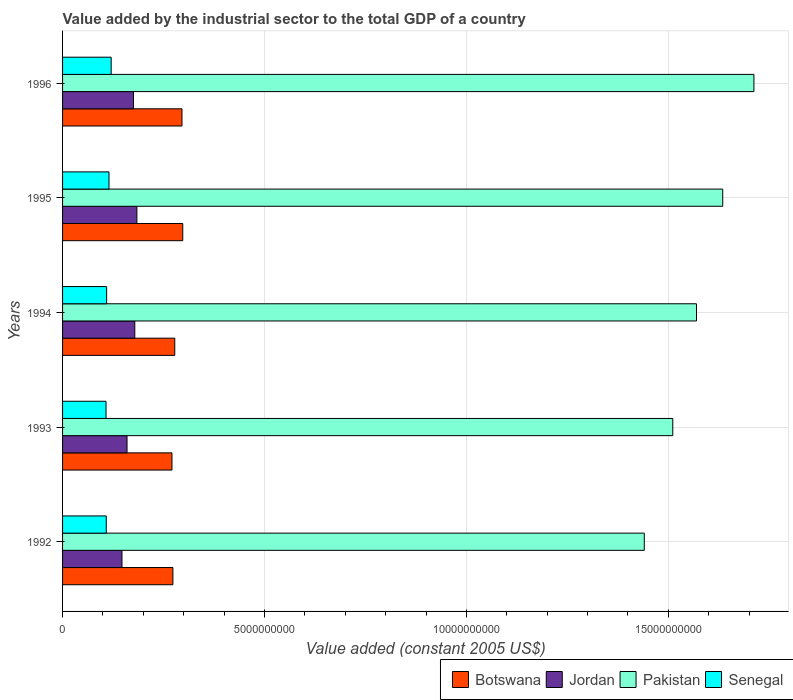How many different coloured bars are there?
Your answer should be very brief. 4. How many groups of bars are there?
Keep it short and to the point. 5. Are the number of bars on each tick of the Y-axis equal?
Make the answer very short. Yes. How many bars are there on the 2nd tick from the top?
Your answer should be compact. 4. What is the label of the 5th group of bars from the top?
Your response must be concise. 1992. In how many cases, is the number of bars for a given year not equal to the number of legend labels?
Ensure brevity in your answer.  0. What is the value added by the industrial sector in Senegal in 1992?
Your response must be concise. 1.08e+09. Across all years, what is the maximum value added by the industrial sector in Senegal?
Give a very brief answer. 1.20e+09. Across all years, what is the minimum value added by the industrial sector in Jordan?
Provide a succinct answer. 1.47e+09. In which year was the value added by the industrial sector in Jordan maximum?
Your answer should be very brief. 1995. In which year was the value added by the industrial sector in Botswana minimum?
Offer a very short reply. 1993. What is the total value added by the industrial sector in Pakistan in the graph?
Make the answer very short. 7.87e+1. What is the difference between the value added by the industrial sector in Pakistan in 1992 and that in 1994?
Your answer should be compact. -1.29e+09. What is the difference between the value added by the industrial sector in Jordan in 1993 and the value added by the industrial sector in Botswana in 1996?
Ensure brevity in your answer.  -1.36e+09. What is the average value added by the industrial sector in Senegal per year?
Your answer should be compact. 1.12e+09. In the year 1993, what is the difference between the value added by the industrial sector in Botswana and value added by the industrial sector in Pakistan?
Your response must be concise. -1.24e+1. What is the ratio of the value added by the industrial sector in Botswana in 1994 to that in 1995?
Provide a succinct answer. 0.93. What is the difference between the highest and the second highest value added by the industrial sector in Senegal?
Your answer should be compact. 5.38e+07. What is the difference between the highest and the lowest value added by the industrial sector in Botswana?
Ensure brevity in your answer.  2.67e+08. In how many years, is the value added by the industrial sector in Pakistan greater than the average value added by the industrial sector in Pakistan taken over all years?
Your answer should be compact. 2. Is it the case that in every year, the sum of the value added by the industrial sector in Senegal and value added by the industrial sector in Pakistan is greater than the sum of value added by the industrial sector in Jordan and value added by the industrial sector in Botswana?
Offer a terse response. No. What does the 4th bar from the top in 1994 represents?
Give a very brief answer. Botswana. What does the 3rd bar from the bottom in 1994 represents?
Provide a short and direct response. Pakistan. Are all the bars in the graph horizontal?
Keep it short and to the point. Yes. What is the difference between two consecutive major ticks on the X-axis?
Provide a succinct answer. 5.00e+09. Are the values on the major ticks of X-axis written in scientific E-notation?
Make the answer very short. No. Does the graph contain any zero values?
Your answer should be very brief. No. How many legend labels are there?
Keep it short and to the point. 4. How are the legend labels stacked?
Make the answer very short. Horizontal. What is the title of the graph?
Your answer should be very brief. Value added by the industrial sector to the total GDP of a country. What is the label or title of the X-axis?
Provide a succinct answer. Value added (constant 2005 US$). What is the label or title of the Y-axis?
Make the answer very short. Years. What is the Value added (constant 2005 US$) of Botswana in 1992?
Your answer should be very brief. 2.73e+09. What is the Value added (constant 2005 US$) of Jordan in 1992?
Your answer should be compact. 1.47e+09. What is the Value added (constant 2005 US$) in Pakistan in 1992?
Your answer should be compact. 1.44e+1. What is the Value added (constant 2005 US$) of Senegal in 1992?
Provide a short and direct response. 1.08e+09. What is the Value added (constant 2005 US$) in Botswana in 1993?
Provide a short and direct response. 2.71e+09. What is the Value added (constant 2005 US$) of Jordan in 1993?
Provide a short and direct response. 1.60e+09. What is the Value added (constant 2005 US$) in Pakistan in 1993?
Keep it short and to the point. 1.51e+1. What is the Value added (constant 2005 US$) of Senegal in 1993?
Provide a succinct answer. 1.08e+09. What is the Value added (constant 2005 US$) in Botswana in 1994?
Offer a very short reply. 2.78e+09. What is the Value added (constant 2005 US$) of Jordan in 1994?
Your response must be concise. 1.79e+09. What is the Value added (constant 2005 US$) of Pakistan in 1994?
Offer a terse response. 1.57e+1. What is the Value added (constant 2005 US$) in Senegal in 1994?
Your response must be concise. 1.09e+09. What is the Value added (constant 2005 US$) in Botswana in 1995?
Your response must be concise. 2.98e+09. What is the Value added (constant 2005 US$) of Jordan in 1995?
Provide a short and direct response. 1.84e+09. What is the Value added (constant 2005 US$) of Pakistan in 1995?
Your response must be concise. 1.63e+1. What is the Value added (constant 2005 US$) of Senegal in 1995?
Provide a succinct answer. 1.15e+09. What is the Value added (constant 2005 US$) in Botswana in 1996?
Your answer should be compact. 2.96e+09. What is the Value added (constant 2005 US$) of Jordan in 1996?
Offer a very short reply. 1.76e+09. What is the Value added (constant 2005 US$) of Pakistan in 1996?
Your answer should be very brief. 1.71e+1. What is the Value added (constant 2005 US$) of Senegal in 1996?
Ensure brevity in your answer.  1.20e+09. Across all years, what is the maximum Value added (constant 2005 US$) in Botswana?
Offer a terse response. 2.98e+09. Across all years, what is the maximum Value added (constant 2005 US$) of Jordan?
Keep it short and to the point. 1.84e+09. Across all years, what is the maximum Value added (constant 2005 US$) in Pakistan?
Your answer should be very brief. 1.71e+1. Across all years, what is the maximum Value added (constant 2005 US$) in Senegal?
Make the answer very short. 1.20e+09. Across all years, what is the minimum Value added (constant 2005 US$) in Botswana?
Ensure brevity in your answer.  2.71e+09. Across all years, what is the minimum Value added (constant 2005 US$) in Jordan?
Provide a succinct answer. 1.47e+09. Across all years, what is the minimum Value added (constant 2005 US$) of Pakistan?
Provide a short and direct response. 1.44e+1. Across all years, what is the minimum Value added (constant 2005 US$) in Senegal?
Offer a terse response. 1.08e+09. What is the total Value added (constant 2005 US$) of Botswana in the graph?
Provide a short and direct response. 1.42e+1. What is the total Value added (constant 2005 US$) of Jordan in the graph?
Give a very brief answer. 8.45e+09. What is the total Value added (constant 2005 US$) in Pakistan in the graph?
Provide a short and direct response. 7.87e+1. What is the total Value added (constant 2005 US$) in Senegal in the graph?
Offer a very short reply. 5.60e+09. What is the difference between the Value added (constant 2005 US$) in Botswana in 1992 and that in 1993?
Your response must be concise. 2.29e+07. What is the difference between the Value added (constant 2005 US$) of Jordan in 1992 and that in 1993?
Your answer should be very brief. -1.25e+08. What is the difference between the Value added (constant 2005 US$) in Pakistan in 1992 and that in 1993?
Provide a succinct answer. -7.05e+08. What is the difference between the Value added (constant 2005 US$) in Senegal in 1992 and that in 1993?
Your answer should be compact. 5.36e+06. What is the difference between the Value added (constant 2005 US$) in Botswana in 1992 and that in 1994?
Give a very brief answer. -4.63e+07. What is the difference between the Value added (constant 2005 US$) in Jordan in 1992 and that in 1994?
Keep it short and to the point. -3.17e+08. What is the difference between the Value added (constant 2005 US$) in Pakistan in 1992 and that in 1994?
Your answer should be very brief. -1.29e+09. What is the difference between the Value added (constant 2005 US$) of Senegal in 1992 and that in 1994?
Offer a very short reply. -9.48e+06. What is the difference between the Value added (constant 2005 US$) in Botswana in 1992 and that in 1995?
Make the answer very short. -2.44e+08. What is the difference between the Value added (constant 2005 US$) in Jordan in 1992 and that in 1995?
Offer a terse response. -3.69e+08. What is the difference between the Value added (constant 2005 US$) in Pakistan in 1992 and that in 1995?
Your answer should be compact. -1.94e+09. What is the difference between the Value added (constant 2005 US$) of Senegal in 1992 and that in 1995?
Provide a short and direct response. -6.81e+07. What is the difference between the Value added (constant 2005 US$) in Botswana in 1992 and that in 1996?
Your answer should be compact. -2.25e+08. What is the difference between the Value added (constant 2005 US$) of Jordan in 1992 and that in 1996?
Provide a succinct answer. -2.85e+08. What is the difference between the Value added (constant 2005 US$) in Pakistan in 1992 and that in 1996?
Offer a terse response. -2.71e+09. What is the difference between the Value added (constant 2005 US$) in Senegal in 1992 and that in 1996?
Your answer should be very brief. -1.22e+08. What is the difference between the Value added (constant 2005 US$) of Botswana in 1993 and that in 1994?
Your response must be concise. -6.92e+07. What is the difference between the Value added (constant 2005 US$) in Jordan in 1993 and that in 1994?
Provide a succinct answer. -1.92e+08. What is the difference between the Value added (constant 2005 US$) in Pakistan in 1993 and that in 1994?
Your answer should be very brief. -5.87e+08. What is the difference between the Value added (constant 2005 US$) in Senegal in 1993 and that in 1994?
Offer a terse response. -1.48e+07. What is the difference between the Value added (constant 2005 US$) in Botswana in 1993 and that in 1995?
Your answer should be very brief. -2.67e+08. What is the difference between the Value added (constant 2005 US$) in Jordan in 1993 and that in 1995?
Keep it short and to the point. -2.44e+08. What is the difference between the Value added (constant 2005 US$) in Pakistan in 1993 and that in 1995?
Your answer should be compact. -1.24e+09. What is the difference between the Value added (constant 2005 US$) of Senegal in 1993 and that in 1995?
Make the answer very short. -7.35e+07. What is the difference between the Value added (constant 2005 US$) in Botswana in 1993 and that in 1996?
Your answer should be compact. -2.48e+08. What is the difference between the Value added (constant 2005 US$) in Jordan in 1993 and that in 1996?
Your answer should be compact. -1.60e+08. What is the difference between the Value added (constant 2005 US$) of Pakistan in 1993 and that in 1996?
Give a very brief answer. -2.01e+09. What is the difference between the Value added (constant 2005 US$) in Senegal in 1993 and that in 1996?
Your response must be concise. -1.27e+08. What is the difference between the Value added (constant 2005 US$) in Botswana in 1994 and that in 1995?
Offer a terse response. -1.98e+08. What is the difference between the Value added (constant 2005 US$) in Jordan in 1994 and that in 1995?
Provide a succinct answer. -5.17e+07. What is the difference between the Value added (constant 2005 US$) in Pakistan in 1994 and that in 1995?
Make the answer very short. -6.50e+08. What is the difference between the Value added (constant 2005 US$) in Senegal in 1994 and that in 1995?
Make the answer very short. -5.86e+07. What is the difference between the Value added (constant 2005 US$) of Botswana in 1994 and that in 1996?
Make the answer very short. -1.79e+08. What is the difference between the Value added (constant 2005 US$) of Jordan in 1994 and that in 1996?
Make the answer very short. 3.27e+07. What is the difference between the Value added (constant 2005 US$) of Pakistan in 1994 and that in 1996?
Offer a terse response. -1.42e+09. What is the difference between the Value added (constant 2005 US$) of Senegal in 1994 and that in 1996?
Offer a very short reply. -1.12e+08. What is the difference between the Value added (constant 2005 US$) in Botswana in 1995 and that in 1996?
Provide a succinct answer. 1.96e+07. What is the difference between the Value added (constant 2005 US$) of Jordan in 1995 and that in 1996?
Keep it short and to the point. 8.45e+07. What is the difference between the Value added (constant 2005 US$) of Pakistan in 1995 and that in 1996?
Ensure brevity in your answer.  -7.72e+08. What is the difference between the Value added (constant 2005 US$) in Senegal in 1995 and that in 1996?
Offer a terse response. -5.38e+07. What is the difference between the Value added (constant 2005 US$) in Botswana in 1992 and the Value added (constant 2005 US$) in Jordan in 1993?
Your answer should be compact. 1.14e+09. What is the difference between the Value added (constant 2005 US$) in Botswana in 1992 and the Value added (constant 2005 US$) in Pakistan in 1993?
Offer a terse response. -1.24e+1. What is the difference between the Value added (constant 2005 US$) of Botswana in 1992 and the Value added (constant 2005 US$) of Senegal in 1993?
Give a very brief answer. 1.66e+09. What is the difference between the Value added (constant 2005 US$) in Jordan in 1992 and the Value added (constant 2005 US$) in Pakistan in 1993?
Give a very brief answer. -1.36e+1. What is the difference between the Value added (constant 2005 US$) in Jordan in 1992 and the Value added (constant 2005 US$) in Senegal in 1993?
Offer a very short reply. 3.95e+08. What is the difference between the Value added (constant 2005 US$) of Pakistan in 1992 and the Value added (constant 2005 US$) of Senegal in 1993?
Provide a short and direct response. 1.33e+1. What is the difference between the Value added (constant 2005 US$) of Botswana in 1992 and the Value added (constant 2005 US$) of Jordan in 1994?
Offer a very short reply. 9.43e+08. What is the difference between the Value added (constant 2005 US$) of Botswana in 1992 and the Value added (constant 2005 US$) of Pakistan in 1994?
Your response must be concise. -1.30e+1. What is the difference between the Value added (constant 2005 US$) of Botswana in 1992 and the Value added (constant 2005 US$) of Senegal in 1994?
Provide a short and direct response. 1.64e+09. What is the difference between the Value added (constant 2005 US$) of Jordan in 1992 and the Value added (constant 2005 US$) of Pakistan in 1994?
Keep it short and to the point. -1.42e+1. What is the difference between the Value added (constant 2005 US$) of Jordan in 1992 and the Value added (constant 2005 US$) of Senegal in 1994?
Provide a short and direct response. 3.80e+08. What is the difference between the Value added (constant 2005 US$) of Pakistan in 1992 and the Value added (constant 2005 US$) of Senegal in 1994?
Give a very brief answer. 1.33e+1. What is the difference between the Value added (constant 2005 US$) of Botswana in 1992 and the Value added (constant 2005 US$) of Jordan in 1995?
Your response must be concise. 8.92e+08. What is the difference between the Value added (constant 2005 US$) in Botswana in 1992 and the Value added (constant 2005 US$) in Pakistan in 1995?
Your response must be concise. -1.36e+1. What is the difference between the Value added (constant 2005 US$) of Botswana in 1992 and the Value added (constant 2005 US$) of Senegal in 1995?
Ensure brevity in your answer.  1.58e+09. What is the difference between the Value added (constant 2005 US$) of Jordan in 1992 and the Value added (constant 2005 US$) of Pakistan in 1995?
Offer a terse response. -1.49e+1. What is the difference between the Value added (constant 2005 US$) in Jordan in 1992 and the Value added (constant 2005 US$) in Senegal in 1995?
Offer a very short reply. 3.21e+08. What is the difference between the Value added (constant 2005 US$) of Pakistan in 1992 and the Value added (constant 2005 US$) of Senegal in 1995?
Provide a short and direct response. 1.33e+1. What is the difference between the Value added (constant 2005 US$) of Botswana in 1992 and the Value added (constant 2005 US$) of Jordan in 1996?
Provide a short and direct response. 9.76e+08. What is the difference between the Value added (constant 2005 US$) in Botswana in 1992 and the Value added (constant 2005 US$) in Pakistan in 1996?
Provide a succinct answer. -1.44e+1. What is the difference between the Value added (constant 2005 US$) of Botswana in 1992 and the Value added (constant 2005 US$) of Senegal in 1996?
Keep it short and to the point. 1.53e+09. What is the difference between the Value added (constant 2005 US$) in Jordan in 1992 and the Value added (constant 2005 US$) in Pakistan in 1996?
Ensure brevity in your answer.  -1.56e+1. What is the difference between the Value added (constant 2005 US$) of Jordan in 1992 and the Value added (constant 2005 US$) of Senegal in 1996?
Ensure brevity in your answer.  2.67e+08. What is the difference between the Value added (constant 2005 US$) in Pakistan in 1992 and the Value added (constant 2005 US$) in Senegal in 1996?
Your answer should be compact. 1.32e+1. What is the difference between the Value added (constant 2005 US$) in Botswana in 1993 and the Value added (constant 2005 US$) in Jordan in 1994?
Provide a succinct answer. 9.20e+08. What is the difference between the Value added (constant 2005 US$) in Botswana in 1993 and the Value added (constant 2005 US$) in Pakistan in 1994?
Keep it short and to the point. -1.30e+1. What is the difference between the Value added (constant 2005 US$) in Botswana in 1993 and the Value added (constant 2005 US$) in Senegal in 1994?
Make the answer very short. 1.62e+09. What is the difference between the Value added (constant 2005 US$) of Jordan in 1993 and the Value added (constant 2005 US$) of Pakistan in 1994?
Your response must be concise. -1.41e+1. What is the difference between the Value added (constant 2005 US$) of Jordan in 1993 and the Value added (constant 2005 US$) of Senegal in 1994?
Offer a terse response. 5.05e+08. What is the difference between the Value added (constant 2005 US$) in Pakistan in 1993 and the Value added (constant 2005 US$) in Senegal in 1994?
Offer a terse response. 1.40e+1. What is the difference between the Value added (constant 2005 US$) of Botswana in 1993 and the Value added (constant 2005 US$) of Jordan in 1995?
Your response must be concise. 8.69e+08. What is the difference between the Value added (constant 2005 US$) in Botswana in 1993 and the Value added (constant 2005 US$) in Pakistan in 1995?
Keep it short and to the point. -1.36e+1. What is the difference between the Value added (constant 2005 US$) of Botswana in 1993 and the Value added (constant 2005 US$) of Senegal in 1995?
Ensure brevity in your answer.  1.56e+09. What is the difference between the Value added (constant 2005 US$) in Jordan in 1993 and the Value added (constant 2005 US$) in Pakistan in 1995?
Offer a terse response. -1.47e+1. What is the difference between the Value added (constant 2005 US$) of Jordan in 1993 and the Value added (constant 2005 US$) of Senegal in 1995?
Give a very brief answer. 4.46e+08. What is the difference between the Value added (constant 2005 US$) of Pakistan in 1993 and the Value added (constant 2005 US$) of Senegal in 1995?
Offer a very short reply. 1.40e+1. What is the difference between the Value added (constant 2005 US$) of Botswana in 1993 and the Value added (constant 2005 US$) of Jordan in 1996?
Offer a very short reply. 9.53e+08. What is the difference between the Value added (constant 2005 US$) in Botswana in 1993 and the Value added (constant 2005 US$) in Pakistan in 1996?
Your answer should be very brief. -1.44e+1. What is the difference between the Value added (constant 2005 US$) of Botswana in 1993 and the Value added (constant 2005 US$) of Senegal in 1996?
Your answer should be compact. 1.51e+09. What is the difference between the Value added (constant 2005 US$) in Jordan in 1993 and the Value added (constant 2005 US$) in Pakistan in 1996?
Provide a succinct answer. -1.55e+1. What is the difference between the Value added (constant 2005 US$) of Jordan in 1993 and the Value added (constant 2005 US$) of Senegal in 1996?
Your answer should be compact. 3.92e+08. What is the difference between the Value added (constant 2005 US$) of Pakistan in 1993 and the Value added (constant 2005 US$) of Senegal in 1996?
Provide a succinct answer. 1.39e+1. What is the difference between the Value added (constant 2005 US$) of Botswana in 1994 and the Value added (constant 2005 US$) of Jordan in 1995?
Provide a short and direct response. 9.38e+08. What is the difference between the Value added (constant 2005 US$) of Botswana in 1994 and the Value added (constant 2005 US$) of Pakistan in 1995?
Keep it short and to the point. -1.36e+1. What is the difference between the Value added (constant 2005 US$) of Botswana in 1994 and the Value added (constant 2005 US$) of Senegal in 1995?
Provide a succinct answer. 1.63e+09. What is the difference between the Value added (constant 2005 US$) in Jordan in 1994 and the Value added (constant 2005 US$) in Pakistan in 1995?
Your response must be concise. -1.46e+1. What is the difference between the Value added (constant 2005 US$) in Jordan in 1994 and the Value added (constant 2005 US$) in Senegal in 1995?
Make the answer very short. 6.39e+08. What is the difference between the Value added (constant 2005 US$) of Pakistan in 1994 and the Value added (constant 2005 US$) of Senegal in 1995?
Keep it short and to the point. 1.45e+1. What is the difference between the Value added (constant 2005 US$) in Botswana in 1994 and the Value added (constant 2005 US$) in Jordan in 1996?
Your answer should be compact. 1.02e+09. What is the difference between the Value added (constant 2005 US$) of Botswana in 1994 and the Value added (constant 2005 US$) of Pakistan in 1996?
Your response must be concise. -1.43e+1. What is the difference between the Value added (constant 2005 US$) of Botswana in 1994 and the Value added (constant 2005 US$) of Senegal in 1996?
Offer a very short reply. 1.57e+09. What is the difference between the Value added (constant 2005 US$) of Jordan in 1994 and the Value added (constant 2005 US$) of Pakistan in 1996?
Ensure brevity in your answer.  -1.53e+1. What is the difference between the Value added (constant 2005 US$) in Jordan in 1994 and the Value added (constant 2005 US$) in Senegal in 1996?
Give a very brief answer. 5.85e+08. What is the difference between the Value added (constant 2005 US$) in Pakistan in 1994 and the Value added (constant 2005 US$) in Senegal in 1996?
Keep it short and to the point. 1.45e+1. What is the difference between the Value added (constant 2005 US$) of Botswana in 1995 and the Value added (constant 2005 US$) of Jordan in 1996?
Provide a short and direct response. 1.22e+09. What is the difference between the Value added (constant 2005 US$) in Botswana in 1995 and the Value added (constant 2005 US$) in Pakistan in 1996?
Make the answer very short. -1.41e+1. What is the difference between the Value added (constant 2005 US$) in Botswana in 1995 and the Value added (constant 2005 US$) in Senegal in 1996?
Offer a terse response. 1.77e+09. What is the difference between the Value added (constant 2005 US$) of Jordan in 1995 and the Value added (constant 2005 US$) of Pakistan in 1996?
Provide a succinct answer. -1.53e+1. What is the difference between the Value added (constant 2005 US$) in Jordan in 1995 and the Value added (constant 2005 US$) in Senegal in 1996?
Keep it short and to the point. 6.37e+08. What is the difference between the Value added (constant 2005 US$) of Pakistan in 1995 and the Value added (constant 2005 US$) of Senegal in 1996?
Ensure brevity in your answer.  1.51e+1. What is the average Value added (constant 2005 US$) in Botswana per year?
Keep it short and to the point. 2.83e+09. What is the average Value added (constant 2005 US$) in Jordan per year?
Make the answer very short. 1.69e+09. What is the average Value added (constant 2005 US$) in Pakistan per year?
Provide a succinct answer. 1.57e+1. What is the average Value added (constant 2005 US$) of Senegal per year?
Your answer should be compact. 1.12e+09. In the year 1992, what is the difference between the Value added (constant 2005 US$) of Botswana and Value added (constant 2005 US$) of Jordan?
Your response must be concise. 1.26e+09. In the year 1992, what is the difference between the Value added (constant 2005 US$) in Botswana and Value added (constant 2005 US$) in Pakistan?
Your answer should be compact. -1.17e+1. In the year 1992, what is the difference between the Value added (constant 2005 US$) of Botswana and Value added (constant 2005 US$) of Senegal?
Ensure brevity in your answer.  1.65e+09. In the year 1992, what is the difference between the Value added (constant 2005 US$) of Jordan and Value added (constant 2005 US$) of Pakistan?
Provide a short and direct response. -1.29e+1. In the year 1992, what is the difference between the Value added (constant 2005 US$) of Jordan and Value added (constant 2005 US$) of Senegal?
Make the answer very short. 3.89e+08. In the year 1992, what is the difference between the Value added (constant 2005 US$) in Pakistan and Value added (constant 2005 US$) in Senegal?
Provide a short and direct response. 1.33e+1. In the year 1993, what is the difference between the Value added (constant 2005 US$) of Botswana and Value added (constant 2005 US$) of Jordan?
Offer a terse response. 1.11e+09. In the year 1993, what is the difference between the Value added (constant 2005 US$) in Botswana and Value added (constant 2005 US$) in Pakistan?
Provide a short and direct response. -1.24e+1. In the year 1993, what is the difference between the Value added (constant 2005 US$) in Botswana and Value added (constant 2005 US$) in Senegal?
Keep it short and to the point. 1.63e+09. In the year 1993, what is the difference between the Value added (constant 2005 US$) of Jordan and Value added (constant 2005 US$) of Pakistan?
Your answer should be compact. -1.35e+1. In the year 1993, what is the difference between the Value added (constant 2005 US$) in Jordan and Value added (constant 2005 US$) in Senegal?
Keep it short and to the point. 5.20e+08. In the year 1993, what is the difference between the Value added (constant 2005 US$) in Pakistan and Value added (constant 2005 US$) in Senegal?
Your answer should be compact. 1.40e+1. In the year 1994, what is the difference between the Value added (constant 2005 US$) in Botswana and Value added (constant 2005 US$) in Jordan?
Your answer should be compact. 9.90e+08. In the year 1994, what is the difference between the Value added (constant 2005 US$) of Botswana and Value added (constant 2005 US$) of Pakistan?
Offer a terse response. -1.29e+1. In the year 1994, what is the difference between the Value added (constant 2005 US$) in Botswana and Value added (constant 2005 US$) in Senegal?
Keep it short and to the point. 1.69e+09. In the year 1994, what is the difference between the Value added (constant 2005 US$) in Jordan and Value added (constant 2005 US$) in Pakistan?
Provide a succinct answer. -1.39e+1. In the year 1994, what is the difference between the Value added (constant 2005 US$) of Jordan and Value added (constant 2005 US$) of Senegal?
Make the answer very short. 6.97e+08. In the year 1994, what is the difference between the Value added (constant 2005 US$) of Pakistan and Value added (constant 2005 US$) of Senegal?
Your answer should be compact. 1.46e+1. In the year 1995, what is the difference between the Value added (constant 2005 US$) of Botswana and Value added (constant 2005 US$) of Jordan?
Your answer should be very brief. 1.14e+09. In the year 1995, what is the difference between the Value added (constant 2005 US$) in Botswana and Value added (constant 2005 US$) in Pakistan?
Ensure brevity in your answer.  -1.34e+1. In the year 1995, what is the difference between the Value added (constant 2005 US$) of Botswana and Value added (constant 2005 US$) of Senegal?
Your response must be concise. 1.83e+09. In the year 1995, what is the difference between the Value added (constant 2005 US$) in Jordan and Value added (constant 2005 US$) in Pakistan?
Give a very brief answer. -1.45e+1. In the year 1995, what is the difference between the Value added (constant 2005 US$) in Jordan and Value added (constant 2005 US$) in Senegal?
Provide a succinct answer. 6.90e+08. In the year 1995, what is the difference between the Value added (constant 2005 US$) in Pakistan and Value added (constant 2005 US$) in Senegal?
Ensure brevity in your answer.  1.52e+1. In the year 1996, what is the difference between the Value added (constant 2005 US$) in Botswana and Value added (constant 2005 US$) in Jordan?
Make the answer very short. 1.20e+09. In the year 1996, what is the difference between the Value added (constant 2005 US$) in Botswana and Value added (constant 2005 US$) in Pakistan?
Give a very brief answer. -1.42e+1. In the year 1996, what is the difference between the Value added (constant 2005 US$) in Botswana and Value added (constant 2005 US$) in Senegal?
Offer a terse response. 1.75e+09. In the year 1996, what is the difference between the Value added (constant 2005 US$) of Jordan and Value added (constant 2005 US$) of Pakistan?
Provide a short and direct response. -1.54e+1. In the year 1996, what is the difference between the Value added (constant 2005 US$) of Jordan and Value added (constant 2005 US$) of Senegal?
Ensure brevity in your answer.  5.52e+08. In the year 1996, what is the difference between the Value added (constant 2005 US$) of Pakistan and Value added (constant 2005 US$) of Senegal?
Provide a short and direct response. 1.59e+1. What is the ratio of the Value added (constant 2005 US$) in Botswana in 1992 to that in 1993?
Keep it short and to the point. 1.01. What is the ratio of the Value added (constant 2005 US$) in Jordan in 1992 to that in 1993?
Offer a terse response. 0.92. What is the ratio of the Value added (constant 2005 US$) in Pakistan in 1992 to that in 1993?
Keep it short and to the point. 0.95. What is the ratio of the Value added (constant 2005 US$) in Senegal in 1992 to that in 1993?
Make the answer very short. 1. What is the ratio of the Value added (constant 2005 US$) in Botswana in 1992 to that in 1994?
Offer a very short reply. 0.98. What is the ratio of the Value added (constant 2005 US$) in Jordan in 1992 to that in 1994?
Your answer should be compact. 0.82. What is the ratio of the Value added (constant 2005 US$) of Pakistan in 1992 to that in 1994?
Your response must be concise. 0.92. What is the ratio of the Value added (constant 2005 US$) in Botswana in 1992 to that in 1995?
Make the answer very short. 0.92. What is the ratio of the Value added (constant 2005 US$) of Jordan in 1992 to that in 1995?
Provide a short and direct response. 0.8. What is the ratio of the Value added (constant 2005 US$) in Pakistan in 1992 to that in 1995?
Your answer should be very brief. 0.88. What is the ratio of the Value added (constant 2005 US$) in Senegal in 1992 to that in 1995?
Ensure brevity in your answer.  0.94. What is the ratio of the Value added (constant 2005 US$) of Botswana in 1992 to that in 1996?
Provide a short and direct response. 0.92. What is the ratio of the Value added (constant 2005 US$) in Jordan in 1992 to that in 1996?
Your answer should be compact. 0.84. What is the ratio of the Value added (constant 2005 US$) of Pakistan in 1992 to that in 1996?
Offer a very short reply. 0.84. What is the ratio of the Value added (constant 2005 US$) in Senegal in 1992 to that in 1996?
Give a very brief answer. 0.9. What is the ratio of the Value added (constant 2005 US$) of Botswana in 1993 to that in 1994?
Offer a very short reply. 0.98. What is the ratio of the Value added (constant 2005 US$) of Jordan in 1993 to that in 1994?
Your answer should be compact. 0.89. What is the ratio of the Value added (constant 2005 US$) in Pakistan in 1993 to that in 1994?
Your answer should be very brief. 0.96. What is the ratio of the Value added (constant 2005 US$) of Senegal in 1993 to that in 1994?
Ensure brevity in your answer.  0.99. What is the ratio of the Value added (constant 2005 US$) of Botswana in 1993 to that in 1995?
Your answer should be very brief. 0.91. What is the ratio of the Value added (constant 2005 US$) in Jordan in 1993 to that in 1995?
Keep it short and to the point. 0.87. What is the ratio of the Value added (constant 2005 US$) of Pakistan in 1993 to that in 1995?
Make the answer very short. 0.92. What is the ratio of the Value added (constant 2005 US$) in Senegal in 1993 to that in 1995?
Offer a very short reply. 0.94. What is the ratio of the Value added (constant 2005 US$) of Botswana in 1993 to that in 1996?
Ensure brevity in your answer.  0.92. What is the ratio of the Value added (constant 2005 US$) of Pakistan in 1993 to that in 1996?
Provide a succinct answer. 0.88. What is the ratio of the Value added (constant 2005 US$) of Senegal in 1993 to that in 1996?
Your response must be concise. 0.89. What is the ratio of the Value added (constant 2005 US$) in Botswana in 1994 to that in 1995?
Offer a very short reply. 0.93. What is the ratio of the Value added (constant 2005 US$) of Jordan in 1994 to that in 1995?
Offer a terse response. 0.97. What is the ratio of the Value added (constant 2005 US$) of Pakistan in 1994 to that in 1995?
Ensure brevity in your answer.  0.96. What is the ratio of the Value added (constant 2005 US$) of Senegal in 1994 to that in 1995?
Offer a terse response. 0.95. What is the ratio of the Value added (constant 2005 US$) in Botswana in 1994 to that in 1996?
Your answer should be very brief. 0.94. What is the ratio of the Value added (constant 2005 US$) of Jordan in 1994 to that in 1996?
Your answer should be very brief. 1.02. What is the ratio of the Value added (constant 2005 US$) of Pakistan in 1994 to that in 1996?
Ensure brevity in your answer.  0.92. What is the ratio of the Value added (constant 2005 US$) in Senegal in 1994 to that in 1996?
Your answer should be compact. 0.91. What is the ratio of the Value added (constant 2005 US$) of Botswana in 1995 to that in 1996?
Provide a succinct answer. 1.01. What is the ratio of the Value added (constant 2005 US$) of Jordan in 1995 to that in 1996?
Make the answer very short. 1.05. What is the ratio of the Value added (constant 2005 US$) in Pakistan in 1995 to that in 1996?
Your response must be concise. 0.95. What is the ratio of the Value added (constant 2005 US$) of Senegal in 1995 to that in 1996?
Make the answer very short. 0.96. What is the difference between the highest and the second highest Value added (constant 2005 US$) in Botswana?
Keep it short and to the point. 1.96e+07. What is the difference between the highest and the second highest Value added (constant 2005 US$) in Jordan?
Your response must be concise. 5.17e+07. What is the difference between the highest and the second highest Value added (constant 2005 US$) in Pakistan?
Give a very brief answer. 7.72e+08. What is the difference between the highest and the second highest Value added (constant 2005 US$) of Senegal?
Provide a succinct answer. 5.38e+07. What is the difference between the highest and the lowest Value added (constant 2005 US$) in Botswana?
Provide a short and direct response. 2.67e+08. What is the difference between the highest and the lowest Value added (constant 2005 US$) in Jordan?
Provide a short and direct response. 3.69e+08. What is the difference between the highest and the lowest Value added (constant 2005 US$) in Pakistan?
Offer a terse response. 2.71e+09. What is the difference between the highest and the lowest Value added (constant 2005 US$) in Senegal?
Ensure brevity in your answer.  1.27e+08. 